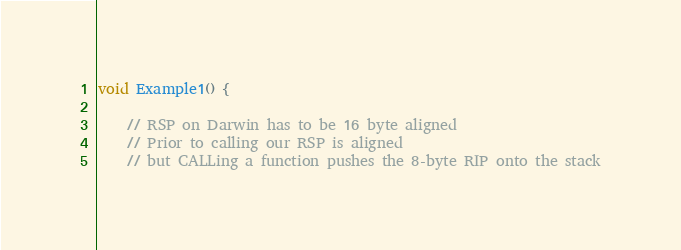<code> <loc_0><loc_0><loc_500><loc_500><_C++_>
void Example1() {

    // RSP on Darwin has to be 16 byte aligned
    // Prior to calling our RSP is aligned
    // but CALLing a function pushes the 8-byte RIP onto the stack
</code> 